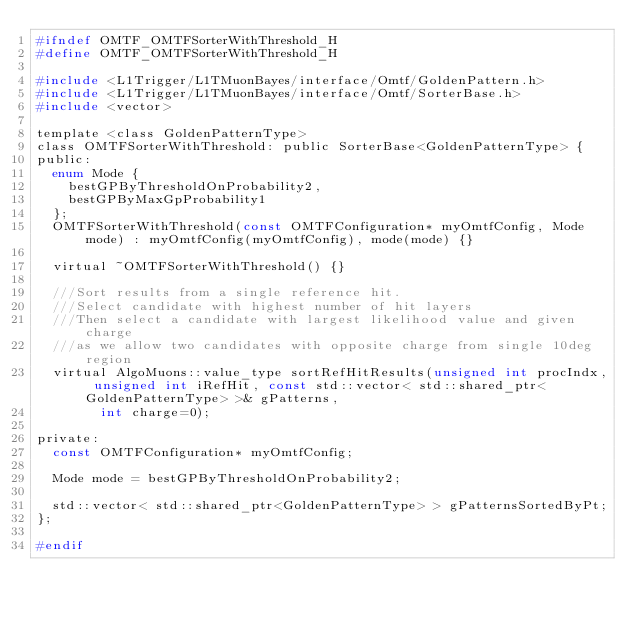Convert code to text. <code><loc_0><loc_0><loc_500><loc_500><_C_>#ifndef OMTF_OMTFSorterWithThreshold_H
#define OMTF_OMTFSorterWithThreshold_H

#include <L1Trigger/L1TMuonBayes/interface/Omtf/GoldenPattern.h>
#include <L1Trigger/L1TMuonBayes/interface/Omtf/SorterBase.h>
#include <vector>

template <class GoldenPatternType>
class OMTFSorterWithThreshold: public SorterBase<GoldenPatternType> {
public:
  enum Mode {
    bestGPByThresholdOnProbability2,
    bestGPByMaxGpProbability1
  };
  OMTFSorterWithThreshold(const OMTFConfiguration* myOmtfConfig, Mode mode) : myOmtfConfig(myOmtfConfig), mode(mode) {}

  virtual ~OMTFSorterWithThreshold() {}

  ///Sort results from a single reference hit.
  ///Select candidate with highest number of hit layers
  ///Then select a candidate with largest likelihood value and given charge
  ///as we allow two candidates with opposite charge from single 10deg region
  virtual AlgoMuons::value_type sortRefHitResults(unsigned int procIndx, unsigned int iRefHit, const std::vector< std::shared_ptr<GoldenPatternType> >& gPatterns,
				int charge=0);

private:
  const OMTFConfiguration* myOmtfConfig;

  Mode mode = bestGPByThresholdOnProbability2;

  std::vector< std::shared_ptr<GoldenPatternType> > gPatternsSortedByPt;
};

#endif
</code> 